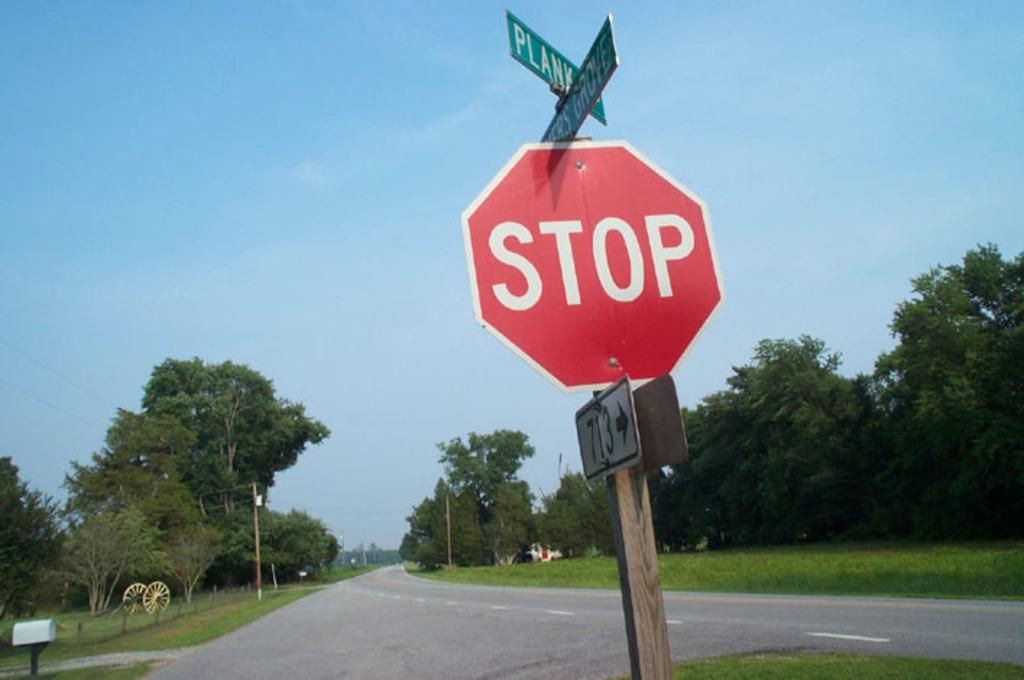<image>
Describe the image concisely. A stop sign in front of an empty road. 